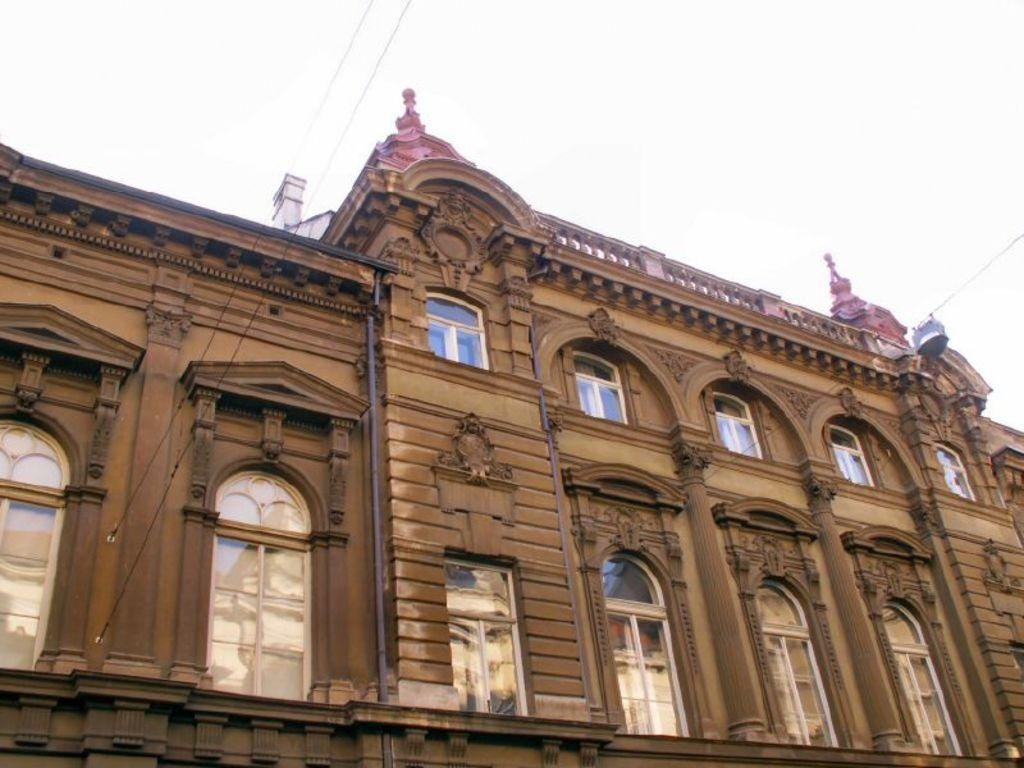What type of structure is present in the image? There is a building in the image. What else can be seen in the image besides the building? There are wires and the sky visible in the image. Can you describe the glass in the image? There is a glass with some reflection in the image. How many fingers can be seen touching the cactus in the image? There is no cactus or fingers present in the image. What type of teeth can be seen in the reflection of the glass? There are no teeth visible in the image, as the reflection in the glass does not show any teeth. 